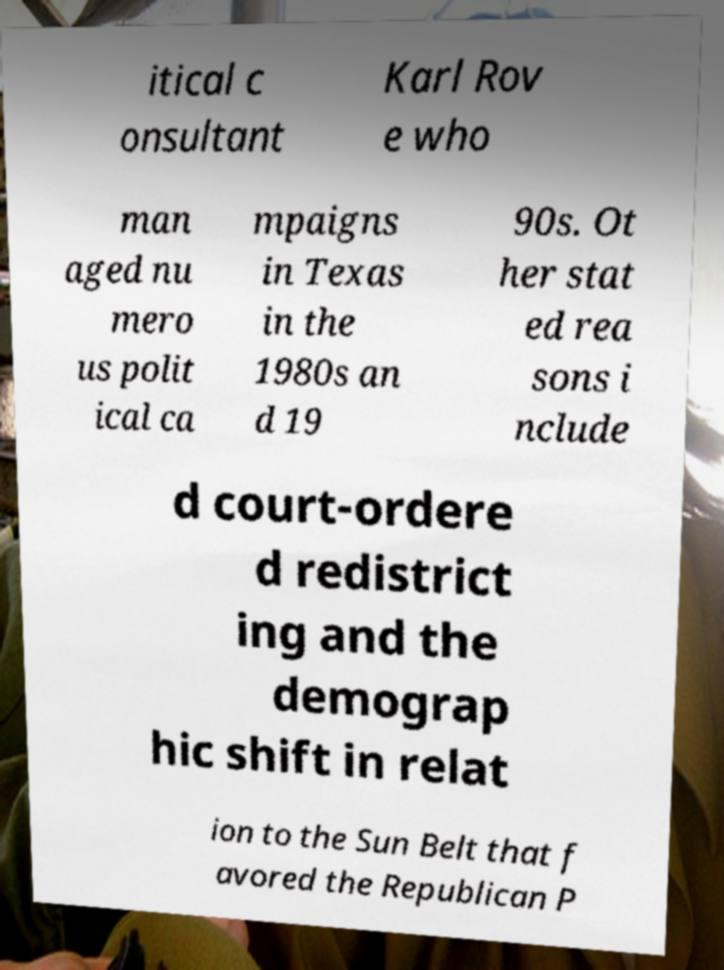What messages or text are displayed in this image? I need them in a readable, typed format. itical c onsultant Karl Rov e who man aged nu mero us polit ical ca mpaigns in Texas in the 1980s an d 19 90s. Ot her stat ed rea sons i nclude d court-ordere d redistrict ing and the demograp hic shift in relat ion to the Sun Belt that f avored the Republican P 